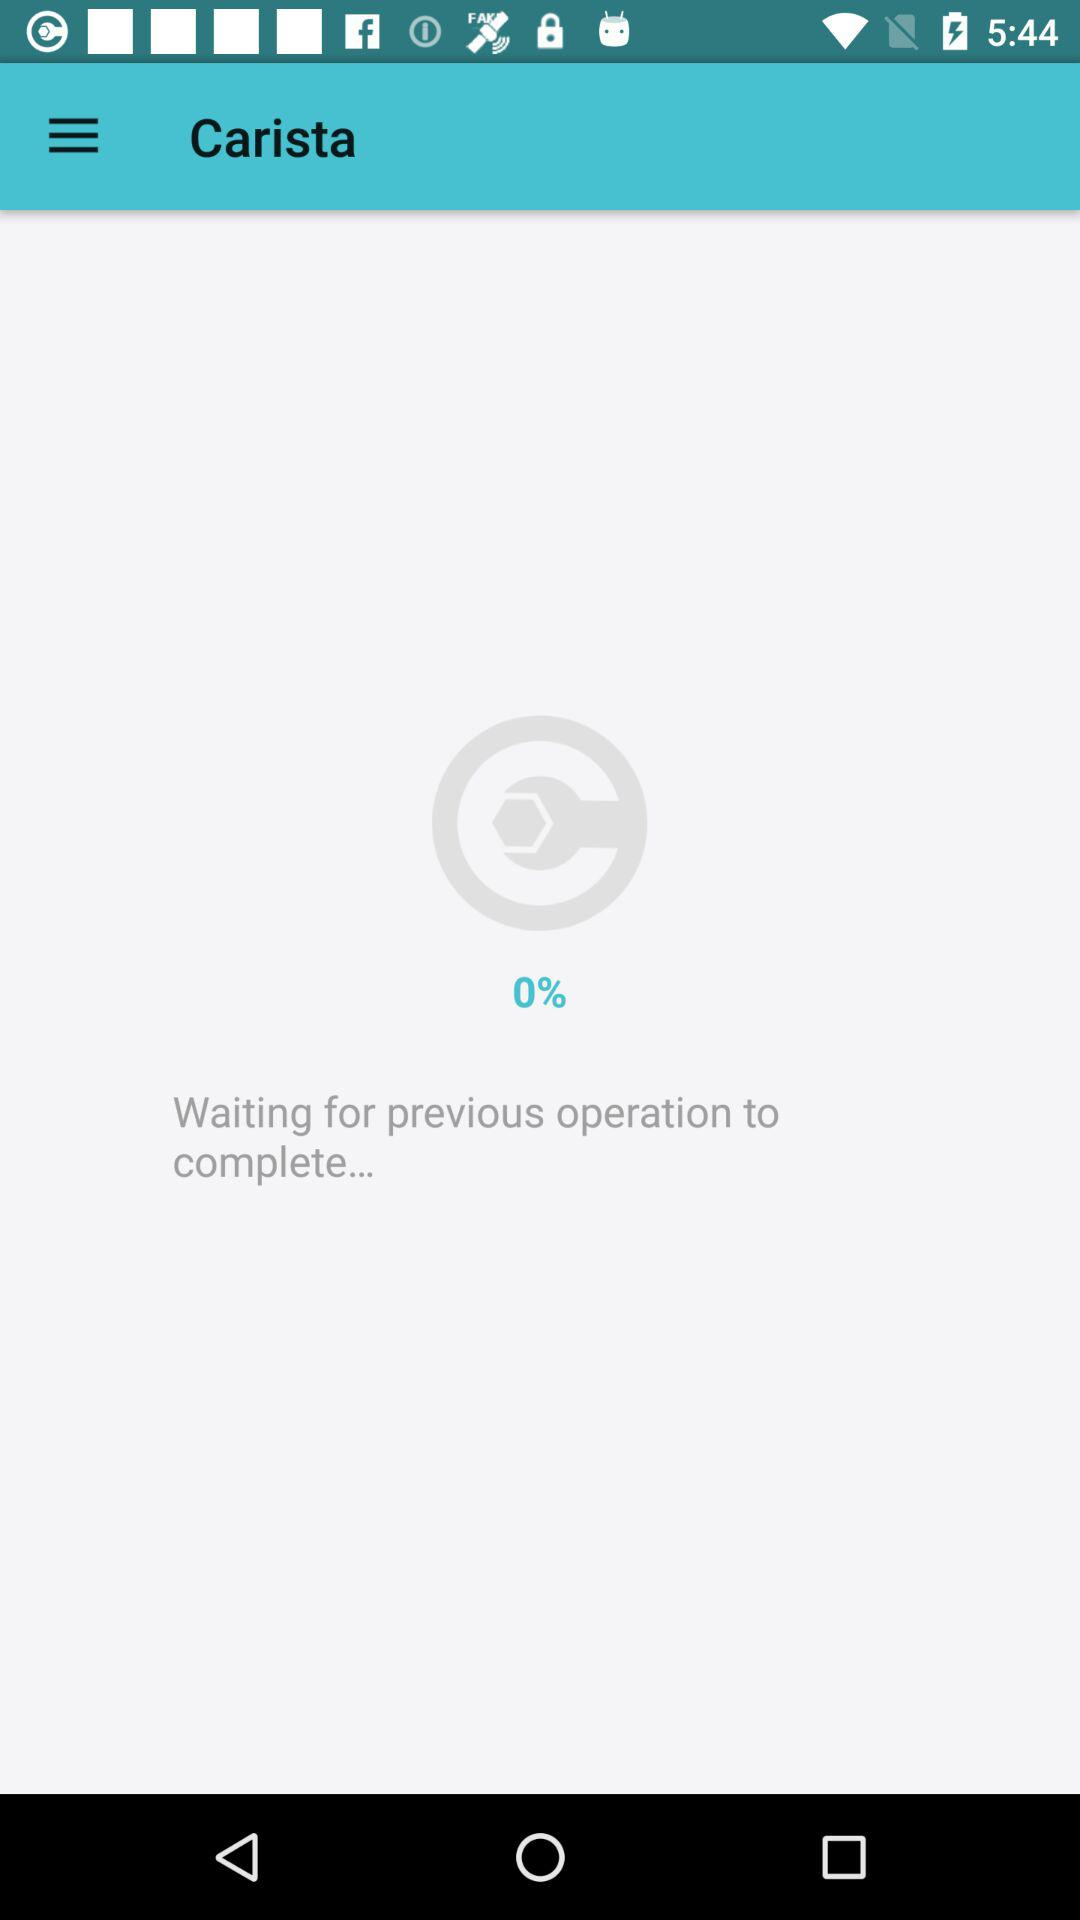What is the percentage of the previous operation that has completed?
Answer the question using a single word or phrase. 0% 